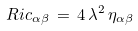Convert formula to latex. <formula><loc_0><loc_0><loc_500><loc_500>R i c _ { \alpha \beta } \, = \, 4 \, \lambda ^ { 2 } \, \eta _ { \alpha \beta }</formula> 